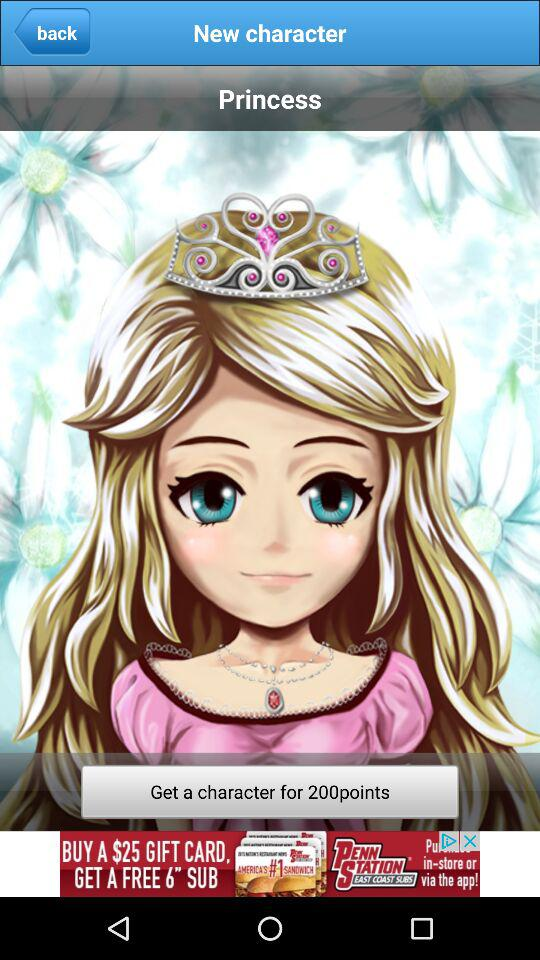For how many points can we get a character? We can get a character for 200 points. 